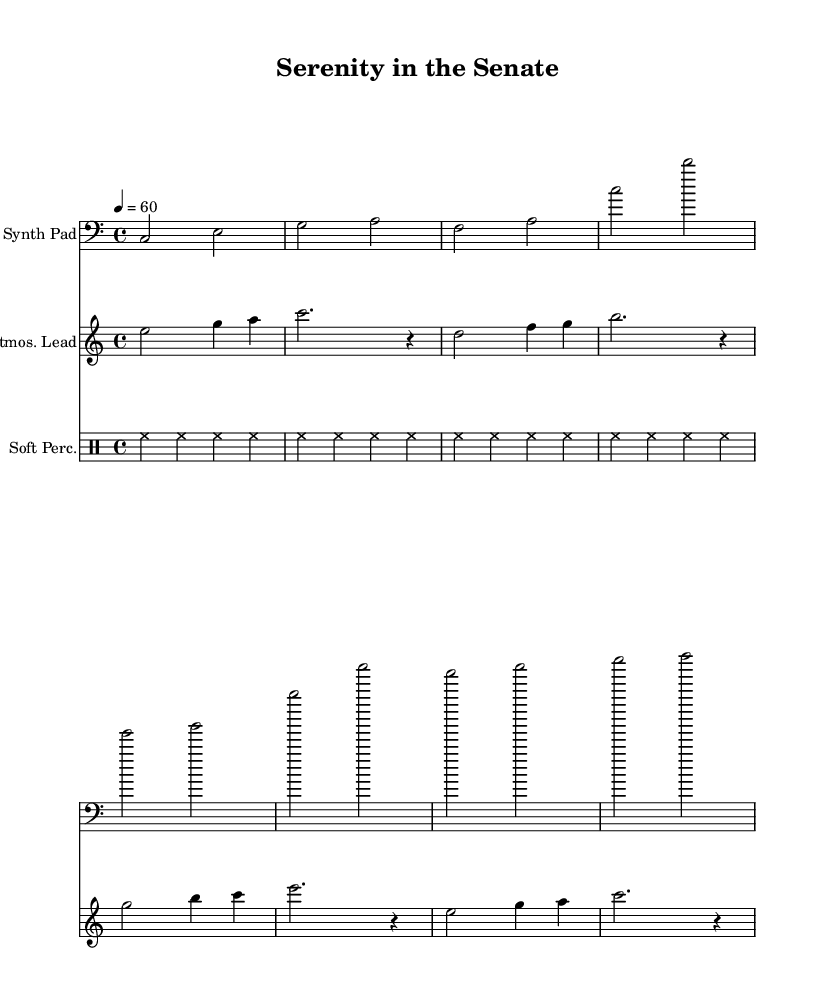What is the key signature of this music? The key signature is C major, which has no sharps or flats.
Answer: C major What is the time signature of this music? The time signature is indicated as 4/4, meaning there are four beats in each measure.
Answer: 4/4 What is the tempo marking of this composition? The tempo marking states 4 = 60, indicating a quarter note beats at sixty beats per minute.
Answer: 60 How many measures are in the Synth Pad section? The Synth Pad section contains four measures, each separated by vertical lines (bars).
Answer: 4 What is the instrument name associated with the atmospheric lead staff? The instrument name for this staff is "Atmos. Lead." This is indicated in the score's title for that staff.
Answer: Atmos. Lead Which rhythmic pattern is used in the Soft Percussion section? The Soft Percussion uses a hi-hat pattern that repeats four times within the section. Each measure contains four hi-hat hits.
Answer: Hi-hat Which two musical components contribute to the ambient soundscape in this piece? The two components are the Synth Pad and the Atmospheric Lead, which together create layers of sound typical of ambient music.
Answer: Synth Pad and Atmospheric Lead 